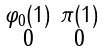Convert formula to latex. <formula><loc_0><loc_0><loc_500><loc_500>\begin{smallmatrix} \varphi _ { 0 } ( 1 ) & \pi ( 1 ) \\ 0 & 0 \end{smallmatrix}</formula> 